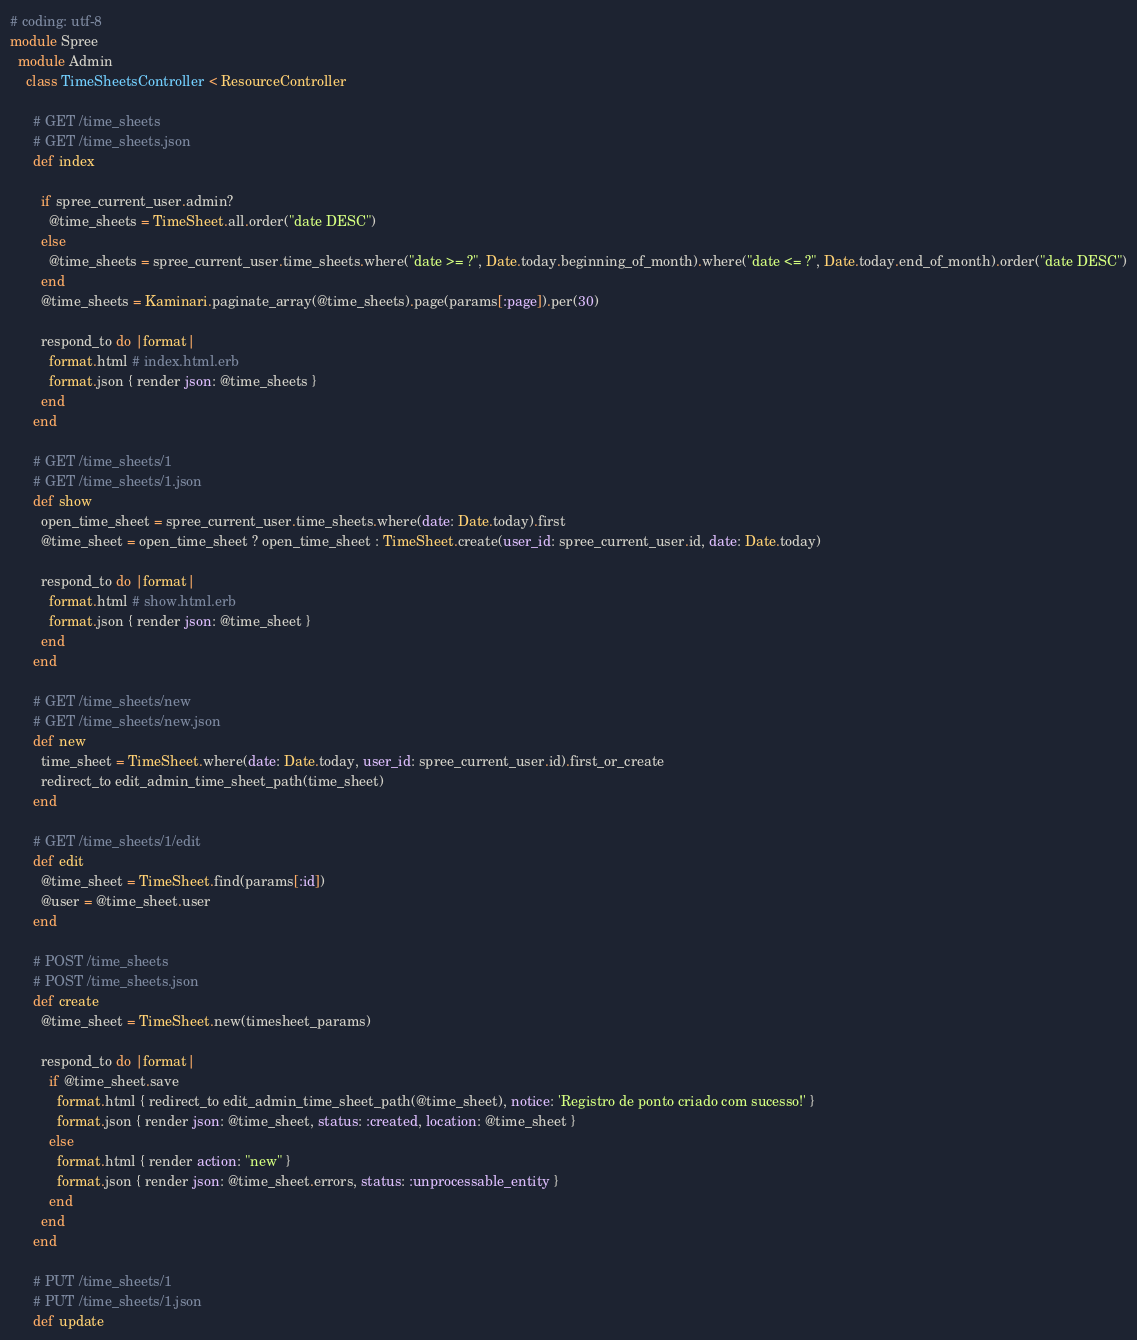Convert code to text. <code><loc_0><loc_0><loc_500><loc_500><_Ruby_># coding: utf-8
module Spree
  module Admin
    class TimeSheetsController < ResourceController
      
      # GET /time_sheets
      # GET /time_sheets.json
      def index
        
        if spree_current_user.admin?
          @time_sheets = TimeSheet.all.order("date DESC")
        else
          @time_sheets = spree_current_user.time_sheets.where("date >= ?", Date.today.beginning_of_month).where("date <= ?", Date.today.end_of_month).order("date DESC")
        end
        @time_sheets = Kaminari.paginate_array(@time_sheets).page(params[:page]).per(30)
        
        respond_to do |format|
          format.html # index.html.erb
          format.json { render json: @time_sheets }
        end
      end

      # GET /time_sheets/1
      # GET /time_sheets/1.json
      def show
        open_time_sheet = spree_current_user.time_sheets.where(date: Date.today).first
        @time_sheet = open_time_sheet ? open_time_sheet : TimeSheet.create(user_id: spree_current_user.id, date: Date.today)

        respond_to do |format|
          format.html # show.html.erb
          format.json { render json: @time_sheet }
        end
      end

      # GET /time_sheets/new
      # GET /time_sheets/new.json
      def new
        time_sheet = TimeSheet.where(date: Date.today, user_id: spree_current_user.id).first_or_create
        redirect_to edit_admin_time_sheet_path(time_sheet)
      end

      # GET /time_sheets/1/edit
      def edit
        @time_sheet = TimeSheet.find(params[:id])
        @user = @time_sheet.user
      end

      # POST /time_sheets
      # POST /time_sheets.json
      def create
        @time_sheet = TimeSheet.new(timesheet_params)

        respond_to do |format|
          if @time_sheet.save
            format.html { redirect_to edit_admin_time_sheet_path(@time_sheet), notice: 'Registro de ponto criado com sucesso!' }
            format.json { render json: @time_sheet, status: :created, location: @time_sheet }
          else
            format.html { render action: "new" }
            format.json { render json: @time_sheet.errors, status: :unprocessable_entity }
          end
        end
      end

      # PUT /time_sheets/1
      # PUT /time_sheets/1.json
      def update</code> 